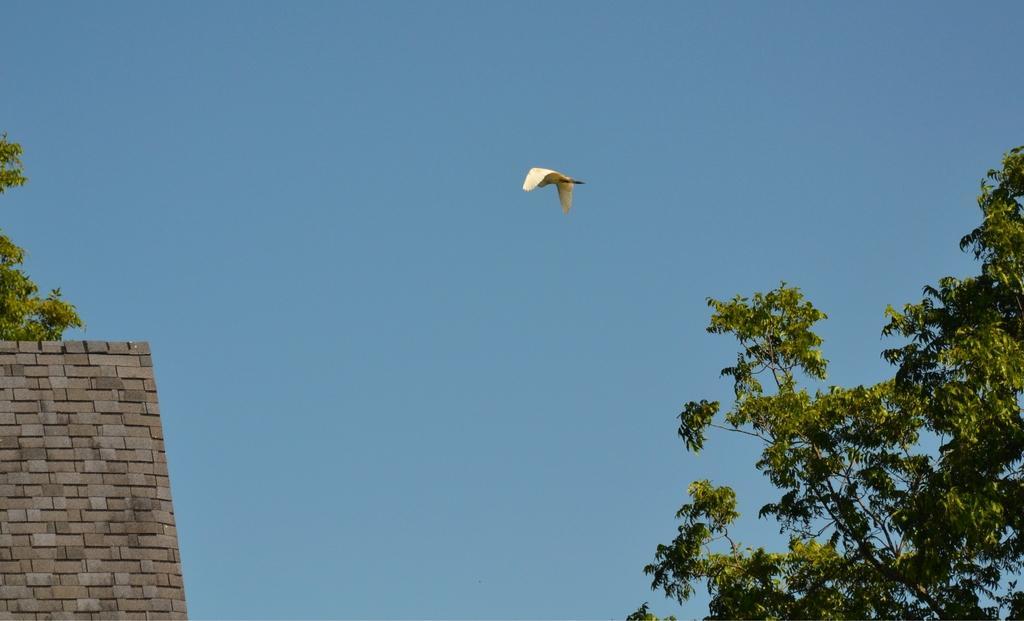Please provide a concise description of this image. In this image we can see a bird flying, there are trees and the wall, in the background, we can see the sky. 